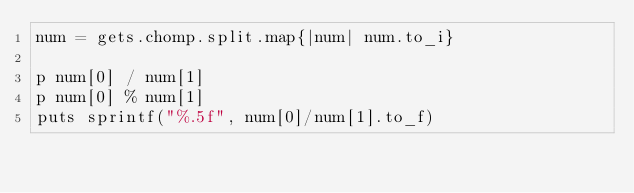<code> <loc_0><loc_0><loc_500><loc_500><_Ruby_>num = gets.chomp.split.map{|num| num.to_i}

p num[0] / num[1]
p num[0] % num[1]
puts sprintf("%.5f", num[0]/num[1].to_f)</code> 